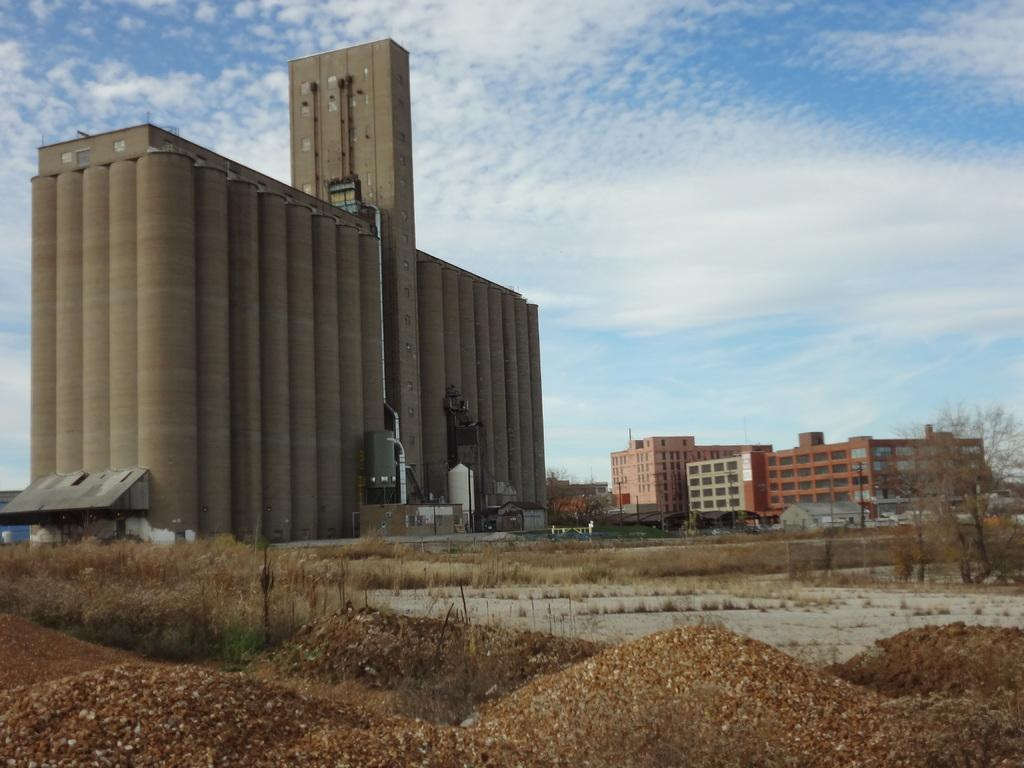What can be seen in the background of the image? There are buildings in the background of the image. How would you describe the land in the foreground? The land in the foreground is covered with dry grass and plants. What type of natural feature is present in the foreground? There are small sand dunes in the foreground. What is visible in the sky in the image? The sky is visible in the image, and clouds are present. Can you see a pencil drawing a picture on the sand dunes in the image? There is no pencil or drawing present in the image; it features buildings, dry grass, plants, and sand dunes. Is there a ghost visible in the image, walking through the sand dunes? There is no ghost present in the image; it only shows buildings, dry grass, plants, and sand dunes. 